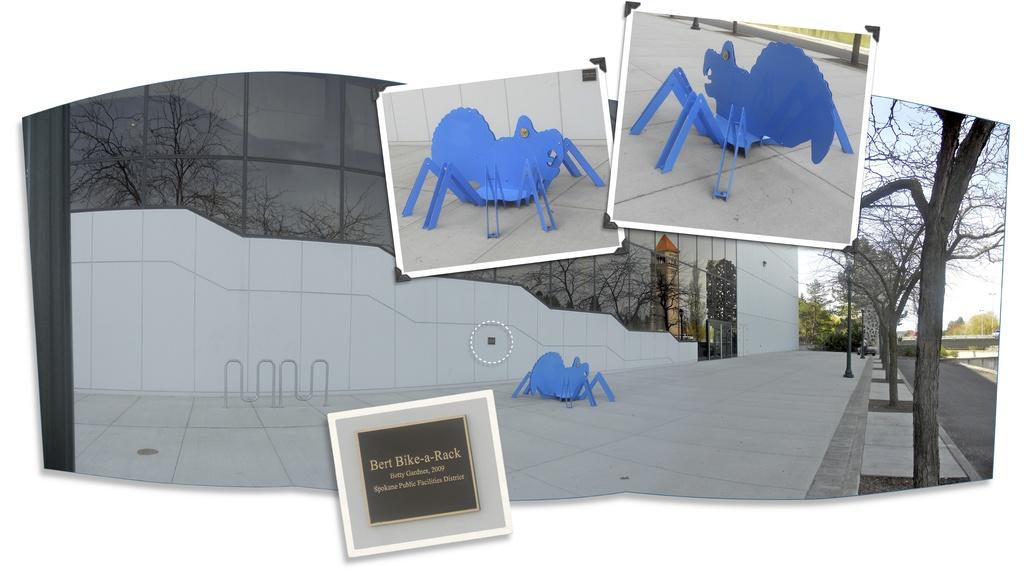What does the small sign say?
Your answer should be very brief. Bert bike-a-rack. What year is written on the sign?
Provide a succinct answer. 2009. 